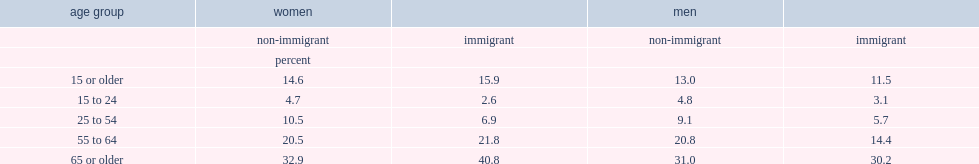What was the percentage of disability among immigrant women aged 15 or older? 15.9. Among women aged 15 to 24, who were more likely to reported having disabilities,non-immigrant women or immigrant women? Non-immigrant. Among women aged 25 to 54, who were more likely to reported having disabilities,non-immigrant women or immigrant women? Non-immigrant. Among women aged 65 or older, who were more likely to reported having disabilities,non-immigrant women or immigrant women? Immigrant. Among immigrants aged 15 or older, who were more likely to reported having disabilities,immigrant women or immigrant men? Immigrant. Among immigrants aged 55 to 64, who were more likely to reported having disabilities,immigrant women or immigrant men? Immigrant. Among immigrants aged 65 or older, who were more likely to reported having disabilities,immigrant women or immigrant men? Immigrant. Among immigrants aged 15 or older, who were more likely to reported having disabilities,non-immigrant women or non-immigrant men? Non-immigrant. Among immigrants aged 25 to 54, who were more likely to reported having disabilities,non-immigrant women or non-immigrant men? Non-immigrant. 